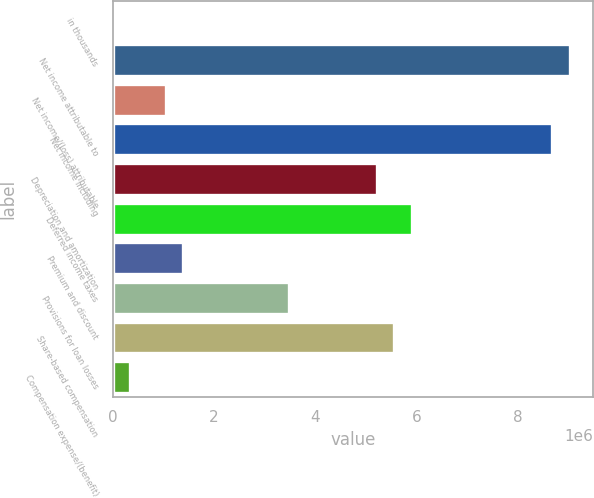Convert chart. <chart><loc_0><loc_0><loc_500><loc_500><bar_chart><fcel>in thousands<fcel>Net income attributable to<fcel>Net income/(loss) attributable<fcel>Net income including<fcel>Depreciation and amortization<fcel>Deferred income taxes<fcel>Premium and discount<fcel>Provisions for loan losses<fcel>Share-based compensation<fcel>Compensation expense/(benefit)<nl><fcel>2018<fcel>9.03415e+06<fcel>1.04419e+06<fcel>8.68676e+06<fcel>5.21286e+06<fcel>5.90764e+06<fcel>1.39158e+06<fcel>3.47591e+06<fcel>5.56025e+06<fcel>349408<nl></chart> 